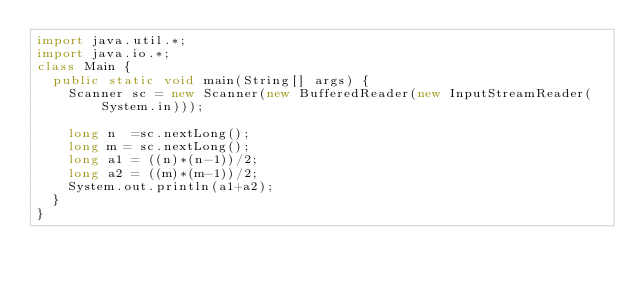<code> <loc_0><loc_0><loc_500><loc_500><_Java_>import java.util.*;
import java.io.*;
class Main {
  public static void main(String[] args) {
    Scanner sc = new Scanner(new BufferedReader(new InputStreamReader(System.in)));
		
		long n  =sc.nextLong();
		long m = sc.nextLong();
		long a1 = ((n)*(n-1))/2;
		long a2 = ((m)*(m-1))/2;
		System.out.println(a1+a2);
	}
}</code> 